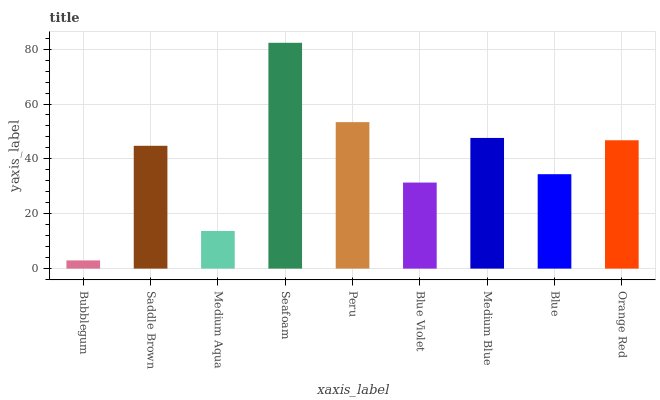Is Bubblegum the minimum?
Answer yes or no. Yes. Is Seafoam the maximum?
Answer yes or no. Yes. Is Saddle Brown the minimum?
Answer yes or no. No. Is Saddle Brown the maximum?
Answer yes or no. No. Is Saddle Brown greater than Bubblegum?
Answer yes or no. Yes. Is Bubblegum less than Saddle Brown?
Answer yes or no. Yes. Is Bubblegum greater than Saddle Brown?
Answer yes or no. No. Is Saddle Brown less than Bubblegum?
Answer yes or no. No. Is Saddle Brown the high median?
Answer yes or no. Yes. Is Saddle Brown the low median?
Answer yes or no. Yes. Is Medium Aqua the high median?
Answer yes or no. No. Is Blue the low median?
Answer yes or no. No. 